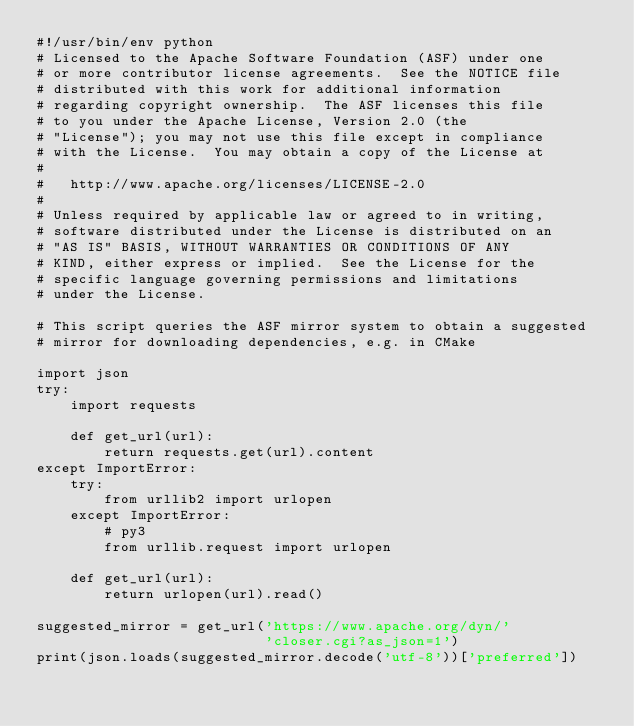<code> <loc_0><loc_0><loc_500><loc_500><_Python_>#!/usr/bin/env python
# Licensed to the Apache Software Foundation (ASF) under one
# or more contributor license agreements.  See the NOTICE file
# distributed with this work for additional information
# regarding copyright ownership.  The ASF licenses this file
# to you under the Apache License, Version 2.0 (the
# "License"); you may not use this file except in compliance
# with the License.  You may obtain a copy of the License at
#
#   http://www.apache.org/licenses/LICENSE-2.0
#
# Unless required by applicable law or agreed to in writing,
# software distributed under the License is distributed on an
# "AS IS" BASIS, WITHOUT WARRANTIES OR CONDITIONS OF ANY
# KIND, either express or implied.  See the License for the
# specific language governing permissions and limitations
# under the License.

# This script queries the ASF mirror system to obtain a suggested
# mirror for downloading dependencies, e.g. in CMake

import json
try:
    import requests

    def get_url(url):
        return requests.get(url).content
except ImportError:
    try:
        from urllib2 import urlopen
    except ImportError:
        # py3
        from urllib.request import urlopen

    def get_url(url):
        return urlopen(url).read()

suggested_mirror = get_url('https://www.apache.org/dyn/'
                           'closer.cgi?as_json=1')
print(json.loads(suggested_mirror.decode('utf-8'))['preferred'])
</code> 